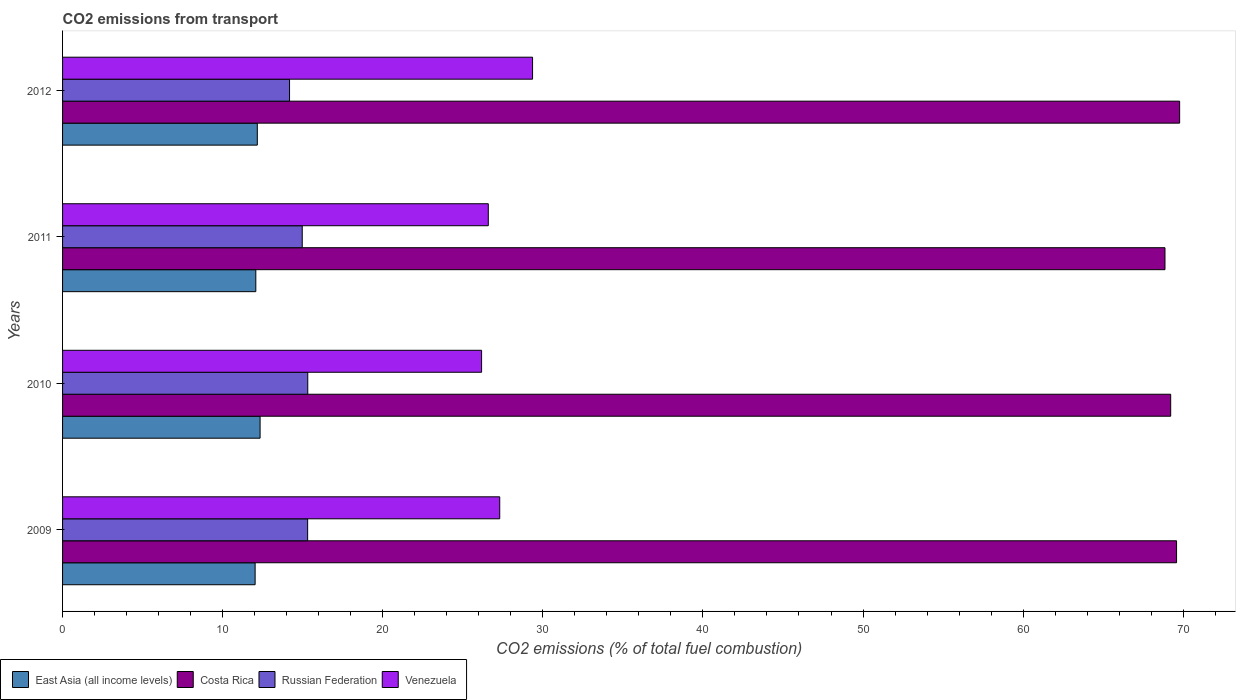Are the number of bars per tick equal to the number of legend labels?
Offer a terse response. Yes. Are the number of bars on each tick of the Y-axis equal?
Provide a succinct answer. Yes. How many bars are there on the 2nd tick from the top?
Give a very brief answer. 4. In how many cases, is the number of bars for a given year not equal to the number of legend labels?
Give a very brief answer. 0. What is the total CO2 emitted in Venezuela in 2009?
Your answer should be compact. 27.31. Across all years, what is the maximum total CO2 emitted in Venezuela?
Provide a succinct answer. 29.36. Across all years, what is the minimum total CO2 emitted in East Asia (all income levels)?
Ensure brevity in your answer.  12.03. In which year was the total CO2 emitted in Costa Rica maximum?
Offer a very short reply. 2012. What is the total total CO2 emitted in Costa Rica in the graph?
Your response must be concise. 277.45. What is the difference between the total CO2 emitted in Russian Federation in 2009 and that in 2011?
Provide a short and direct response. 0.34. What is the difference between the total CO2 emitted in Russian Federation in 2009 and the total CO2 emitted in Venezuela in 2011?
Keep it short and to the point. -11.28. What is the average total CO2 emitted in East Asia (all income levels) per year?
Give a very brief answer. 12.15. In the year 2011, what is the difference between the total CO2 emitted in Venezuela and total CO2 emitted in East Asia (all income levels)?
Make the answer very short. 14.52. What is the ratio of the total CO2 emitted in Venezuela in 2010 to that in 2011?
Give a very brief answer. 0.98. What is the difference between the highest and the second highest total CO2 emitted in Costa Rica?
Your response must be concise. 0.19. What is the difference between the highest and the lowest total CO2 emitted in East Asia (all income levels)?
Make the answer very short. 0.31. In how many years, is the total CO2 emitted in Venezuela greater than the average total CO2 emitted in Venezuela taken over all years?
Ensure brevity in your answer.  1. What does the 2nd bar from the top in 2010 represents?
Ensure brevity in your answer.  Russian Federation. What does the 3rd bar from the bottom in 2009 represents?
Ensure brevity in your answer.  Russian Federation. Is it the case that in every year, the sum of the total CO2 emitted in East Asia (all income levels) and total CO2 emitted in Costa Rica is greater than the total CO2 emitted in Russian Federation?
Make the answer very short. Yes. Are the values on the major ticks of X-axis written in scientific E-notation?
Provide a succinct answer. No. Does the graph contain any zero values?
Offer a terse response. No. Where does the legend appear in the graph?
Provide a succinct answer. Bottom left. How are the legend labels stacked?
Your answer should be compact. Horizontal. What is the title of the graph?
Your answer should be very brief. CO2 emissions from transport. What is the label or title of the X-axis?
Make the answer very short. CO2 emissions (% of total fuel combustion). What is the CO2 emissions (% of total fuel combustion) in East Asia (all income levels) in 2009?
Provide a short and direct response. 12.03. What is the CO2 emissions (% of total fuel combustion) of Costa Rica in 2009?
Offer a very short reply. 69.59. What is the CO2 emissions (% of total fuel combustion) in Russian Federation in 2009?
Give a very brief answer. 15.31. What is the CO2 emissions (% of total fuel combustion) of Venezuela in 2009?
Your response must be concise. 27.31. What is the CO2 emissions (% of total fuel combustion) of East Asia (all income levels) in 2010?
Your response must be concise. 12.34. What is the CO2 emissions (% of total fuel combustion) in Costa Rica in 2010?
Offer a very short reply. 69.22. What is the CO2 emissions (% of total fuel combustion) of Russian Federation in 2010?
Make the answer very short. 15.32. What is the CO2 emissions (% of total fuel combustion) of Venezuela in 2010?
Make the answer very short. 26.17. What is the CO2 emissions (% of total fuel combustion) in East Asia (all income levels) in 2011?
Your answer should be compact. 12.07. What is the CO2 emissions (% of total fuel combustion) of Costa Rica in 2011?
Provide a succinct answer. 68.86. What is the CO2 emissions (% of total fuel combustion) of Russian Federation in 2011?
Provide a short and direct response. 14.97. What is the CO2 emissions (% of total fuel combustion) of Venezuela in 2011?
Your answer should be compact. 26.59. What is the CO2 emissions (% of total fuel combustion) in East Asia (all income levels) in 2012?
Your response must be concise. 12.16. What is the CO2 emissions (% of total fuel combustion) in Costa Rica in 2012?
Provide a short and direct response. 69.78. What is the CO2 emissions (% of total fuel combustion) of Russian Federation in 2012?
Your answer should be very brief. 14.18. What is the CO2 emissions (% of total fuel combustion) of Venezuela in 2012?
Provide a short and direct response. 29.36. Across all years, what is the maximum CO2 emissions (% of total fuel combustion) of East Asia (all income levels)?
Your answer should be very brief. 12.34. Across all years, what is the maximum CO2 emissions (% of total fuel combustion) of Costa Rica?
Ensure brevity in your answer.  69.78. Across all years, what is the maximum CO2 emissions (% of total fuel combustion) in Russian Federation?
Make the answer very short. 15.32. Across all years, what is the maximum CO2 emissions (% of total fuel combustion) of Venezuela?
Your answer should be very brief. 29.36. Across all years, what is the minimum CO2 emissions (% of total fuel combustion) in East Asia (all income levels)?
Your answer should be compact. 12.03. Across all years, what is the minimum CO2 emissions (% of total fuel combustion) of Costa Rica?
Provide a succinct answer. 68.86. Across all years, what is the minimum CO2 emissions (% of total fuel combustion) of Russian Federation?
Your response must be concise. 14.18. Across all years, what is the minimum CO2 emissions (% of total fuel combustion) in Venezuela?
Keep it short and to the point. 26.17. What is the total CO2 emissions (% of total fuel combustion) of East Asia (all income levels) in the graph?
Keep it short and to the point. 48.6. What is the total CO2 emissions (% of total fuel combustion) of Costa Rica in the graph?
Offer a terse response. 277.44. What is the total CO2 emissions (% of total fuel combustion) of Russian Federation in the graph?
Your answer should be very brief. 59.77. What is the total CO2 emissions (% of total fuel combustion) in Venezuela in the graph?
Keep it short and to the point. 109.43. What is the difference between the CO2 emissions (% of total fuel combustion) of East Asia (all income levels) in 2009 and that in 2010?
Provide a short and direct response. -0.31. What is the difference between the CO2 emissions (% of total fuel combustion) of Costa Rica in 2009 and that in 2010?
Ensure brevity in your answer.  0.37. What is the difference between the CO2 emissions (% of total fuel combustion) of Russian Federation in 2009 and that in 2010?
Give a very brief answer. -0.01. What is the difference between the CO2 emissions (% of total fuel combustion) in Venezuela in 2009 and that in 2010?
Provide a succinct answer. 1.13. What is the difference between the CO2 emissions (% of total fuel combustion) in East Asia (all income levels) in 2009 and that in 2011?
Your answer should be compact. -0.04. What is the difference between the CO2 emissions (% of total fuel combustion) of Costa Rica in 2009 and that in 2011?
Make the answer very short. 0.72. What is the difference between the CO2 emissions (% of total fuel combustion) in Russian Federation in 2009 and that in 2011?
Provide a short and direct response. 0.34. What is the difference between the CO2 emissions (% of total fuel combustion) in Venezuela in 2009 and that in 2011?
Ensure brevity in your answer.  0.71. What is the difference between the CO2 emissions (% of total fuel combustion) of East Asia (all income levels) in 2009 and that in 2012?
Provide a succinct answer. -0.14. What is the difference between the CO2 emissions (% of total fuel combustion) in Costa Rica in 2009 and that in 2012?
Your response must be concise. -0.19. What is the difference between the CO2 emissions (% of total fuel combustion) in Russian Federation in 2009 and that in 2012?
Your response must be concise. 1.13. What is the difference between the CO2 emissions (% of total fuel combustion) of Venezuela in 2009 and that in 2012?
Ensure brevity in your answer.  -2.05. What is the difference between the CO2 emissions (% of total fuel combustion) of East Asia (all income levels) in 2010 and that in 2011?
Offer a terse response. 0.27. What is the difference between the CO2 emissions (% of total fuel combustion) in Costa Rica in 2010 and that in 2011?
Offer a very short reply. 0.36. What is the difference between the CO2 emissions (% of total fuel combustion) of Russian Federation in 2010 and that in 2011?
Provide a succinct answer. 0.35. What is the difference between the CO2 emissions (% of total fuel combustion) of Venezuela in 2010 and that in 2011?
Offer a terse response. -0.42. What is the difference between the CO2 emissions (% of total fuel combustion) of East Asia (all income levels) in 2010 and that in 2012?
Provide a succinct answer. 0.17. What is the difference between the CO2 emissions (% of total fuel combustion) in Costa Rica in 2010 and that in 2012?
Keep it short and to the point. -0.56. What is the difference between the CO2 emissions (% of total fuel combustion) in Russian Federation in 2010 and that in 2012?
Give a very brief answer. 1.14. What is the difference between the CO2 emissions (% of total fuel combustion) in Venezuela in 2010 and that in 2012?
Offer a terse response. -3.18. What is the difference between the CO2 emissions (% of total fuel combustion) in East Asia (all income levels) in 2011 and that in 2012?
Your response must be concise. -0.09. What is the difference between the CO2 emissions (% of total fuel combustion) of Costa Rica in 2011 and that in 2012?
Keep it short and to the point. -0.92. What is the difference between the CO2 emissions (% of total fuel combustion) of Russian Federation in 2011 and that in 2012?
Give a very brief answer. 0.79. What is the difference between the CO2 emissions (% of total fuel combustion) of Venezuela in 2011 and that in 2012?
Provide a succinct answer. -2.76. What is the difference between the CO2 emissions (% of total fuel combustion) of East Asia (all income levels) in 2009 and the CO2 emissions (% of total fuel combustion) of Costa Rica in 2010?
Your response must be concise. -57.19. What is the difference between the CO2 emissions (% of total fuel combustion) of East Asia (all income levels) in 2009 and the CO2 emissions (% of total fuel combustion) of Russian Federation in 2010?
Make the answer very short. -3.29. What is the difference between the CO2 emissions (% of total fuel combustion) in East Asia (all income levels) in 2009 and the CO2 emissions (% of total fuel combustion) in Venezuela in 2010?
Make the answer very short. -14.15. What is the difference between the CO2 emissions (% of total fuel combustion) of Costa Rica in 2009 and the CO2 emissions (% of total fuel combustion) of Russian Federation in 2010?
Keep it short and to the point. 54.27. What is the difference between the CO2 emissions (% of total fuel combustion) of Costa Rica in 2009 and the CO2 emissions (% of total fuel combustion) of Venezuela in 2010?
Offer a very short reply. 43.41. What is the difference between the CO2 emissions (% of total fuel combustion) in Russian Federation in 2009 and the CO2 emissions (% of total fuel combustion) in Venezuela in 2010?
Provide a short and direct response. -10.87. What is the difference between the CO2 emissions (% of total fuel combustion) of East Asia (all income levels) in 2009 and the CO2 emissions (% of total fuel combustion) of Costa Rica in 2011?
Make the answer very short. -56.83. What is the difference between the CO2 emissions (% of total fuel combustion) in East Asia (all income levels) in 2009 and the CO2 emissions (% of total fuel combustion) in Russian Federation in 2011?
Give a very brief answer. -2.94. What is the difference between the CO2 emissions (% of total fuel combustion) in East Asia (all income levels) in 2009 and the CO2 emissions (% of total fuel combustion) in Venezuela in 2011?
Make the answer very short. -14.57. What is the difference between the CO2 emissions (% of total fuel combustion) in Costa Rica in 2009 and the CO2 emissions (% of total fuel combustion) in Russian Federation in 2011?
Your response must be concise. 54.61. What is the difference between the CO2 emissions (% of total fuel combustion) of Costa Rica in 2009 and the CO2 emissions (% of total fuel combustion) of Venezuela in 2011?
Keep it short and to the point. 42.99. What is the difference between the CO2 emissions (% of total fuel combustion) in Russian Federation in 2009 and the CO2 emissions (% of total fuel combustion) in Venezuela in 2011?
Your answer should be compact. -11.28. What is the difference between the CO2 emissions (% of total fuel combustion) in East Asia (all income levels) in 2009 and the CO2 emissions (% of total fuel combustion) in Costa Rica in 2012?
Your answer should be compact. -57.75. What is the difference between the CO2 emissions (% of total fuel combustion) of East Asia (all income levels) in 2009 and the CO2 emissions (% of total fuel combustion) of Russian Federation in 2012?
Provide a short and direct response. -2.15. What is the difference between the CO2 emissions (% of total fuel combustion) in East Asia (all income levels) in 2009 and the CO2 emissions (% of total fuel combustion) in Venezuela in 2012?
Keep it short and to the point. -17.33. What is the difference between the CO2 emissions (% of total fuel combustion) in Costa Rica in 2009 and the CO2 emissions (% of total fuel combustion) in Russian Federation in 2012?
Offer a terse response. 55.41. What is the difference between the CO2 emissions (% of total fuel combustion) of Costa Rica in 2009 and the CO2 emissions (% of total fuel combustion) of Venezuela in 2012?
Keep it short and to the point. 40.23. What is the difference between the CO2 emissions (% of total fuel combustion) of Russian Federation in 2009 and the CO2 emissions (% of total fuel combustion) of Venezuela in 2012?
Give a very brief answer. -14.05. What is the difference between the CO2 emissions (% of total fuel combustion) in East Asia (all income levels) in 2010 and the CO2 emissions (% of total fuel combustion) in Costa Rica in 2011?
Make the answer very short. -56.52. What is the difference between the CO2 emissions (% of total fuel combustion) of East Asia (all income levels) in 2010 and the CO2 emissions (% of total fuel combustion) of Russian Federation in 2011?
Offer a terse response. -2.63. What is the difference between the CO2 emissions (% of total fuel combustion) of East Asia (all income levels) in 2010 and the CO2 emissions (% of total fuel combustion) of Venezuela in 2011?
Give a very brief answer. -14.26. What is the difference between the CO2 emissions (% of total fuel combustion) in Costa Rica in 2010 and the CO2 emissions (% of total fuel combustion) in Russian Federation in 2011?
Ensure brevity in your answer.  54.25. What is the difference between the CO2 emissions (% of total fuel combustion) of Costa Rica in 2010 and the CO2 emissions (% of total fuel combustion) of Venezuela in 2011?
Offer a terse response. 42.63. What is the difference between the CO2 emissions (% of total fuel combustion) in Russian Federation in 2010 and the CO2 emissions (% of total fuel combustion) in Venezuela in 2011?
Give a very brief answer. -11.28. What is the difference between the CO2 emissions (% of total fuel combustion) in East Asia (all income levels) in 2010 and the CO2 emissions (% of total fuel combustion) in Costa Rica in 2012?
Keep it short and to the point. -57.44. What is the difference between the CO2 emissions (% of total fuel combustion) of East Asia (all income levels) in 2010 and the CO2 emissions (% of total fuel combustion) of Russian Federation in 2012?
Your answer should be compact. -1.84. What is the difference between the CO2 emissions (% of total fuel combustion) in East Asia (all income levels) in 2010 and the CO2 emissions (% of total fuel combustion) in Venezuela in 2012?
Offer a terse response. -17.02. What is the difference between the CO2 emissions (% of total fuel combustion) of Costa Rica in 2010 and the CO2 emissions (% of total fuel combustion) of Russian Federation in 2012?
Keep it short and to the point. 55.04. What is the difference between the CO2 emissions (% of total fuel combustion) in Costa Rica in 2010 and the CO2 emissions (% of total fuel combustion) in Venezuela in 2012?
Make the answer very short. 39.86. What is the difference between the CO2 emissions (% of total fuel combustion) of Russian Federation in 2010 and the CO2 emissions (% of total fuel combustion) of Venezuela in 2012?
Make the answer very short. -14.04. What is the difference between the CO2 emissions (% of total fuel combustion) in East Asia (all income levels) in 2011 and the CO2 emissions (% of total fuel combustion) in Costa Rica in 2012?
Offer a very short reply. -57.71. What is the difference between the CO2 emissions (% of total fuel combustion) of East Asia (all income levels) in 2011 and the CO2 emissions (% of total fuel combustion) of Russian Federation in 2012?
Your answer should be very brief. -2.11. What is the difference between the CO2 emissions (% of total fuel combustion) in East Asia (all income levels) in 2011 and the CO2 emissions (% of total fuel combustion) in Venezuela in 2012?
Offer a very short reply. -17.29. What is the difference between the CO2 emissions (% of total fuel combustion) in Costa Rica in 2011 and the CO2 emissions (% of total fuel combustion) in Russian Federation in 2012?
Your response must be concise. 54.68. What is the difference between the CO2 emissions (% of total fuel combustion) in Costa Rica in 2011 and the CO2 emissions (% of total fuel combustion) in Venezuela in 2012?
Make the answer very short. 39.5. What is the difference between the CO2 emissions (% of total fuel combustion) of Russian Federation in 2011 and the CO2 emissions (% of total fuel combustion) of Venezuela in 2012?
Ensure brevity in your answer.  -14.39. What is the average CO2 emissions (% of total fuel combustion) in East Asia (all income levels) per year?
Your answer should be compact. 12.15. What is the average CO2 emissions (% of total fuel combustion) of Costa Rica per year?
Provide a succinct answer. 69.36. What is the average CO2 emissions (% of total fuel combustion) of Russian Federation per year?
Make the answer very short. 14.94. What is the average CO2 emissions (% of total fuel combustion) of Venezuela per year?
Keep it short and to the point. 27.36. In the year 2009, what is the difference between the CO2 emissions (% of total fuel combustion) in East Asia (all income levels) and CO2 emissions (% of total fuel combustion) in Costa Rica?
Ensure brevity in your answer.  -57.56. In the year 2009, what is the difference between the CO2 emissions (% of total fuel combustion) of East Asia (all income levels) and CO2 emissions (% of total fuel combustion) of Russian Federation?
Ensure brevity in your answer.  -3.28. In the year 2009, what is the difference between the CO2 emissions (% of total fuel combustion) in East Asia (all income levels) and CO2 emissions (% of total fuel combustion) in Venezuela?
Ensure brevity in your answer.  -15.28. In the year 2009, what is the difference between the CO2 emissions (% of total fuel combustion) in Costa Rica and CO2 emissions (% of total fuel combustion) in Russian Federation?
Ensure brevity in your answer.  54.28. In the year 2009, what is the difference between the CO2 emissions (% of total fuel combustion) in Costa Rica and CO2 emissions (% of total fuel combustion) in Venezuela?
Keep it short and to the point. 42.28. In the year 2009, what is the difference between the CO2 emissions (% of total fuel combustion) in Russian Federation and CO2 emissions (% of total fuel combustion) in Venezuela?
Your response must be concise. -12. In the year 2010, what is the difference between the CO2 emissions (% of total fuel combustion) in East Asia (all income levels) and CO2 emissions (% of total fuel combustion) in Costa Rica?
Keep it short and to the point. -56.88. In the year 2010, what is the difference between the CO2 emissions (% of total fuel combustion) of East Asia (all income levels) and CO2 emissions (% of total fuel combustion) of Russian Federation?
Provide a succinct answer. -2.98. In the year 2010, what is the difference between the CO2 emissions (% of total fuel combustion) of East Asia (all income levels) and CO2 emissions (% of total fuel combustion) of Venezuela?
Make the answer very short. -13.84. In the year 2010, what is the difference between the CO2 emissions (% of total fuel combustion) of Costa Rica and CO2 emissions (% of total fuel combustion) of Russian Federation?
Offer a terse response. 53.9. In the year 2010, what is the difference between the CO2 emissions (% of total fuel combustion) of Costa Rica and CO2 emissions (% of total fuel combustion) of Venezuela?
Make the answer very short. 43.04. In the year 2010, what is the difference between the CO2 emissions (% of total fuel combustion) in Russian Federation and CO2 emissions (% of total fuel combustion) in Venezuela?
Your answer should be very brief. -10.86. In the year 2011, what is the difference between the CO2 emissions (% of total fuel combustion) of East Asia (all income levels) and CO2 emissions (% of total fuel combustion) of Costa Rica?
Offer a very short reply. -56.79. In the year 2011, what is the difference between the CO2 emissions (% of total fuel combustion) in East Asia (all income levels) and CO2 emissions (% of total fuel combustion) in Russian Federation?
Give a very brief answer. -2.9. In the year 2011, what is the difference between the CO2 emissions (% of total fuel combustion) in East Asia (all income levels) and CO2 emissions (% of total fuel combustion) in Venezuela?
Offer a very short reply. -14.52. In the year 2011, what is the difference between the CO2 emissions (% of total fuel combustion) in Costa Rica and CO2 emissions (% of total fuel combustion) in Russian Federation?
Ensure brevity in your answer.  53.89. In the year 2011, what is the difference between the CO2 emissions (% of total fuel combustion) in Costa Rica and CO2 emissions (% of total fuel combustion) in Venezuela?
Your answer should be very brief. 42.27. In the year 2011, what is the difference between the CO2 emissions (% of total fuel combustion) of Russian Federation and CO2 emissions (% of total fuel combustion) of Venezuela?
Provide a succinct answer. -11.62. In the year 2012, what is the difference between the CO2 emissions (% of total fuel combustion) of East Asia (all income levels) and CO2 emissions (% of total fuel combustion) of Costa Rica?
Offer a very short reply. -57.61. In the year 2012, what is the difference between the CO2 emissions (% of total fuel combustion) of East Asia (all income levels) and CO2 emissions (% of total fuel combustion) of Russian Federation?
Ensure brevity in your answer.  -2.01. In the year 2012, what is the difference between the CO2 emissions (% of total fuel combustion) in East Asia (all income levels) and CO2 emissions (% of total fuel combustion) in Venezuela?
Give a very brief answer. -17.19. In the year 2012, what is the difference between the CO2 emissions (% of total fuel combustion) of Costa Rica and CO2 emissions (% of total fuel combustion) of Russian Federation?
Your answer should be very brief. 55.6. In the year 2012, what is the difference between the CO2 emissions (% of total fuel combustion) of Costa Rica and CO2 emissions (% of total fuel combustion) of Venezuela?
Your answer should be compact. 40.42. In the year 2012, what is the difference between the CO2 emissions (% of total fuel combustion) of Russian Federation and CO2 emissions (% of total fuel combustion) of Venezuela?
Offer a terse response. -15.18. What is the ratio of the CO2 emissions (% of total fuel combustion) in East Asia (all income levels) in 2009 to that in 2010?
Offer a very short reply. 0.97. What is the ratio of the CO2 emissions (% of total fuel combustion) in Costa Rica in 2009 to that in 2010?
Make the answer very short. 1.01. What is the ratio of the CO2 emissions (% of total fuel combustion) in Venezuela in 2009 to that in 2010?
Give a very brief answer. 1.04. What is the ratio of the CO2 emissions (% of total fuel combustion) of Costa Rica in 2009 to that in 2011?
Your answer should be compact. 1.01. What is the ratio of the CO2 emissions (% of total fuel combustion) of Russian Federation in 2009 to that in 2011?
Offer a terse response. 1.02. What is the ratio of the CO2 emissions (% of total fuel combustion) in Venezuela in 2009 to that in 2011?
Keep it short and to the point. 1.03. What is the ratio of the CO2 emissions (% of total fuel combustion) in Costa Rica in 2009 to that in 2012?
Offer a terse response. 1. What is the ratio of the CO2 emissions (% of total fuel combustion) in Russian Federation in 2009 to that in 2012?
Your answer should be compact. 1.08. What is the ratio of the CO2 emissions (% of total fuel combustion) of Venezuela in 2009 to that in 2012?
Your answer should be very brief. 0.93. What is the ratio of the CO2 emissions (% of total fuel combustion) in East Asia (all income levels) in 2010 to that in 2011?
Keep it short and to the point. 1.02. What is the ratio of the CO2 emissions (% of total fuel combustion) in Russian Federation in 2010 to that in 2011?
Make the answer very short. 1.02. What is the ratio of the CO2 emissions (% of total fuel combustion) in Venezuela in 2010 to that in 2011?
Offer a very short reply. 0.98. What is the ratio of the CO2 emissions (% of total fuel combustion) of East Asia (all income levels) in 2010 to that in 2012?
Offer a very short reply. 1.01. What is the ratio of the CO2 emissions (% of total fuel combustion) in Costa Rica in 2010 to that in 2012?
Offer a terse response. 0.99. What is the ratio of the CO2 emissions (% of total fuel combustion) in Russian Federation in 2010 to that in 2012?
Offer a terse response. 1.08. What is the ratio of the CO2 emissions (% of total fuel combustion) of Venezuela in 2010 to that in 2012?
Give a very brief answer. 0.89. What is the ratio of the CO2 emissions (% of total fuel combustion) of East Asia (all income levels) in 2011 to that in 2012?
Offer a terse response. 0.99. What is the ratio of the CO2 emissions (% of total fuel combustion) in Costa Rica in 2011 to that in 2012?
Provide a succinct answer. 0.99. What is the ratio of the CO2 emissions (% of total fuel combustion) of Russian Federation in 2011 to that in 2012?
Your answer should be compact. 1.06. What is the ratio of the CO2 emissions (% of total fuel combustion) in Venezuela in 2011 to that in 2012?
Ensure brevity in your answer.  0.91. What is the difference between the highest and the second highest CO2 emissions (% of total fuel combustion) of East Asia (all income levels)?
Offer a very short reply. 0.17. What is the difference between the highest and the second highest CO2 emissions (% of total fuel combustion) in Costa Rica?
Ensure brevity in your answer.  0.19. What is the difference between the highest and the second highest CO2 emissions (% of total fuel combustion) of Russian Federation?
Your response must be concise. 0.01. What is the difference between the highest and the second highest CO2 emissions (% of total fuel combustion) of Venezuela?
Your answer should be compact. 2.05. What is the difference between the highest and the lowest CO2 emissions (% of total fuel combustion) in East Asia (all income levels)?
Offer a terse response. 0.31. What is the difference between the highest and the lowest CO2 emissions (% of total fuel combustion) of Costa Rica?
Provide a succinct answer. 0.92. What is the difference between the highest and the lowest CO2 emissions (% of total fuel combustion) of Russian Federation?
Your response must be concise. 1.14. What is the difference between the highest and the lowest CO2 emissions (% of total fuel combustion) of Venezuela?
Provide a succinct answer. 3.18. 